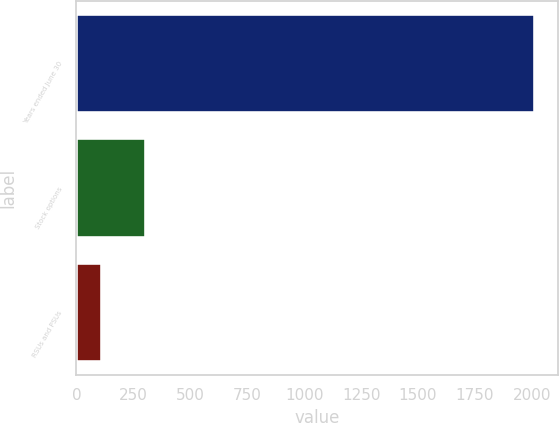Convert chart to OTSL. <chart><loc_0><loc_0><loc_500><loc_500><bar_chart><fcel>Years ended June 30<fcel>Stock options<fcel>RSUs and PSUs<nl><fcel>2015<fcel>304.1<fcel>114<nl></chart> 